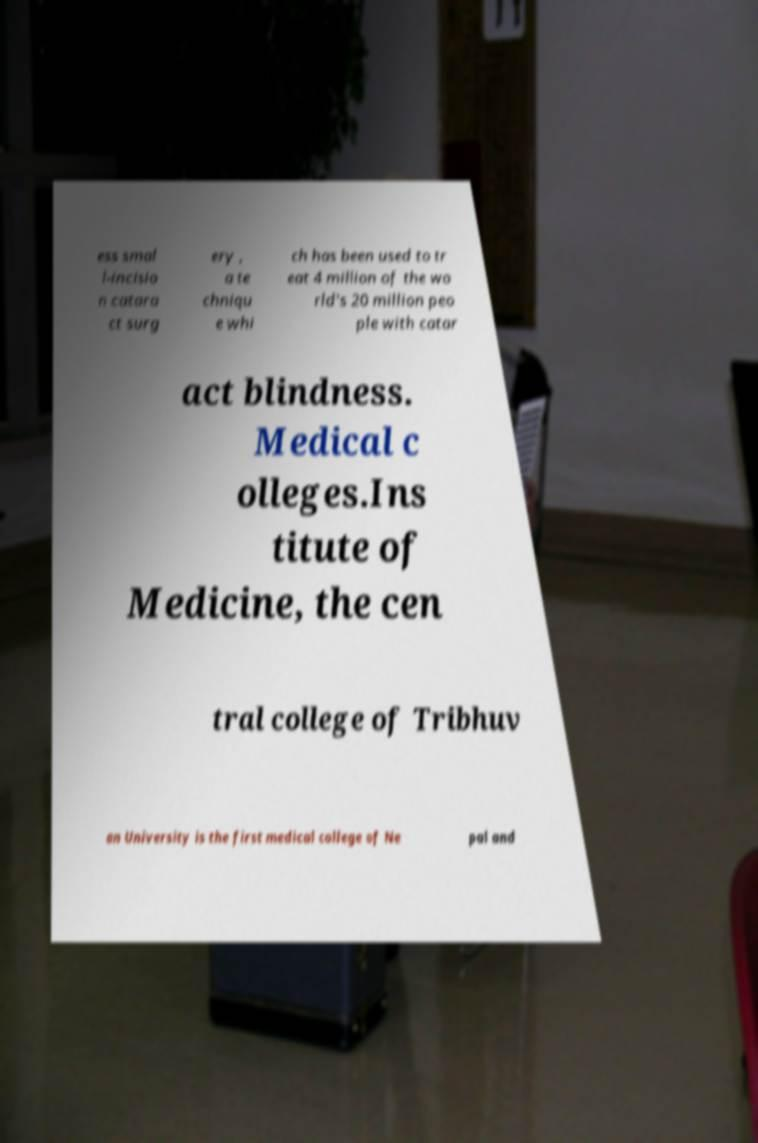For documentation purposes, I need the text within this image transcribed. Could you provide that? ess smal l-incisio n catara ct surg ery , a te chniqu e whi ch has been used to tr eat 4 million of the wo rld's 20 million peo ple with catar act blindness. Medical c olleges.Ins titute of Medicine, the cen tral college of Tribhuv an University is the first medical college of Ne pal and 